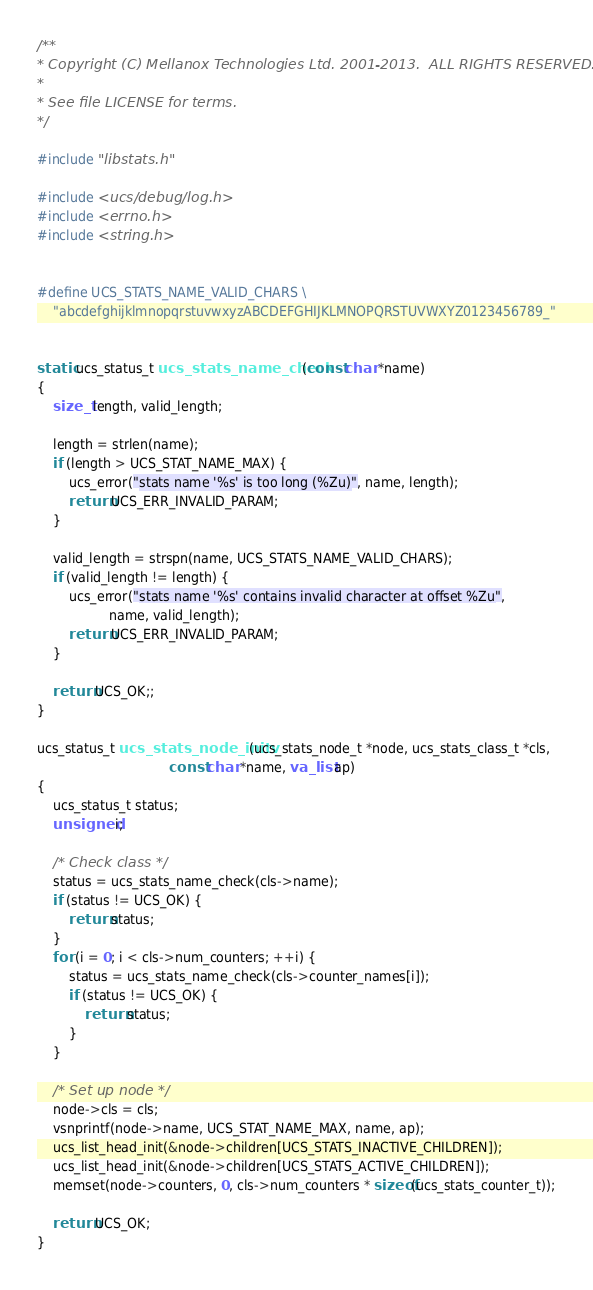<code> <loc_0><loc_0><loc_500><loc_500><_C_>/**
* Copyright (C) Mellanox Technologies Ltd. 2001-2013.  ALL RIGHTS RESERVED.
*
* See file LICENSE for terms.
*/

#include "libstats.h"

#include <ucs/debug/log.h>
#include <errno.h>
#include <string.h>


#define UCS_STATS_NAME_VALID_CHARS \
    "abcdefghijklmnopqrstuvwxyzABCDEFGHIJKLMNOPQRSTUVWXYZ0123456789_"


static ucs_status_t ucs_stats_name_check(const char *name)
{
    size_t length, valid_length;

    length = strlen(name);
    if (length > UCS_STAT_NAME_MAX) {
        ucs_error("stats name '%s' is too long (%Zu)", name, length);
        return UCS_ERR_INVALID_PARAM;
    }

    valid_length = strspn(name, UCS_STATS_NAME_VALID_CHARS);
    if (valid_length != length) {
        ucs_error("stats name '%s' contains invalid character at offset %Zu",
                  name, valid_length);
        return UCS_ERR_INVALID_PARAM;
    }

    return UCS_OK;;
}

ucs_status_t ucs_stats_node_initv(ucs_stats_node_t *node, ucs_stats_class_t *cls,
                                 const char *name, va_list ap)
{
    ucs_status_t status;
    unsigned i;

    /* Check class */
    status = ucs_stats_name_check(cls->name);
    if (status != UCS_OK) {
        return status;
    }
    for (i = 0; i < cls->num_counters; ++i) {
        status = ucs_stats_name_check(cls->counter_names[i]);
        if (status != UCS_OK) {
            return status;
        }
    }

    /* Set up node */
    node->cls = cls;
    vsnprintf(node->name, UCS_STAT_NAME_MAX, name, ap);
    ucs_list_head_init(&node->children[UCS_STATS_INACTIVE_CHILDREN]);
    ucs_list_head_init(&node->children[UCS_STATS_ACTIVE_CHILDREN]);
    memset(node->counters, 0, cls->num_counters * sizeof(ucs_stats_counter_t));

    return UCS_OK;
}

</code> 